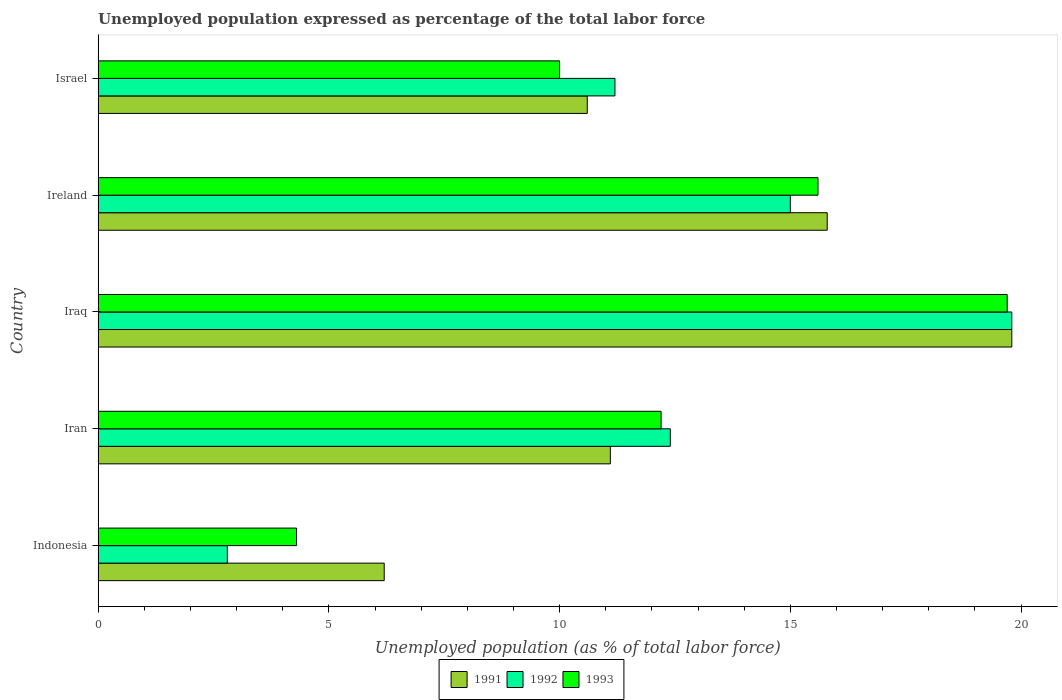How many different coloured bars are there?
Provide a short and direct response. 3. Are the number of bars on each tick of the Y-axis equal?
Provide a succinct answer. Yes. How many bars are there on the 2nd tick from the top?
Offer a terse response. 3. What is the label of the 4th group of bars from the top?
Your answer should be compact. Iran. In how many cases, is the number of bars for a given country not equal to the number of legend labels?
Keep it short and to the point. 0. What is the unemployment in in 1991 in Iraq?
Your answer should be compact. 19.8. Across all countries, what is the maximum unemployment in in 1991?
Provide a succinct answer. 19.8. Across all countries, what is the minimum unemployment in in 1991?
Give a very brief answer. 6.2. In which country was the unemployment in in 1992 maximum?
Your answer should be very brief. Iraq. What is the total unemployment in in 1993 in the graph?
Your answer should be very brief. 61.8. What is the difference between the unemployment in in 1993 in Iran and that in Ireland?
Provide a succinct answer. -3.4. What is the difference between the unemployment in in 1991 in Iraq and the unemployment in in 1993 in Ireland?
Make the answer very short. 4.2. What is the average unemployment in in 1991 per country?
Your answer should be compact. 12.7. What is the difference between the unemployment in in 1992 and unemployment in in 1993 in Iraq?
Your answer should be compact. 0.1. What is the ratio of the unemployment in in 1992 in Iran to that in Ireland?
Your answer should be compact. 0.83. Is the unemployment in in 1992 in Iraq less than that in Israel?
Provide a succinct answer. No. What is the difference between the highest and the second highest unemployment in in 1992?
Provide a short and direct response. 4.8. What is the difference between the highest and the lowest unemployment in in 1993?
Provide a short and direct response. 15.4. What does the 3rd bar from the bottom in Iran represents?
Offer a terse response. 1993. Is it the case that in every country, the sum of the unemployment in in 1993 and unemployment in in 1992 is greater than the unemployment in in 1991?
Provide a short and direct response. Yes. How many bars are there?
Ensure brevity in your answer.  15. Are all the bars in the graph horizontal?
Offer a very short reply. Yes. Does the graph contain any zero values?
Make the answer very short. No. What is the title of the graph?
Your answer should be compact. Unemployed population expressed as percentage of the total labor force. Does "2005" appear as one of the legend labels in the graph?
Keep it short and to the point. No. What is the label or title of the X-axis?
Ensure brevity in your answer.  Unemployed population (as % of total labor force). What is the Unemployed population (as % of total labor force) of 1991 in Indonesia?
Offer a very short reply. 6.2. What is the Unemployed population (as % of total labor force) in 1992 in Indonesia?
Ensure brevity in your answer.  2.8. What is the Unemployed population (as % of total labor force) of 1993 in Indonesia?
Provide a short and direct response. 4.3. What is the Unemployed population (as % of total labor force) of 1991 in Iran?
Offer a terse response. 11.1. What is the Unemployed population (as % of total labor force) of 1992 in Iran?
Keep it short and to the point. 12.4. What is the Unemployed population (as % of total labor force) of 1993 in Iran?
Your answer should be compact. 12.2. What is the Unemployed population (as % of total labor force) of 1991 in Iraq?
Make the answer very short. 19.8. What is the Unemployed population (as % of total labor force) of 1992 in Iraq?
Offer a very short reply. 19.8. What is the Unemployed population (as % of total labor force) of 1993 in Iraq?
Your answer should be very brief. 19.7. What is the Unemployed population (as % of total labor force) of 1991 in Ireland?
Make the answer very short. 15.8. What is the Unemployed population (as % of total labor force) in 1992 in Ireland?
Your answer should be compact. 15. What is the Unemployed population (as % of total labor force) of 1993 in Ireland?
Your answer should be very brief. 15.6. What is the Unemployed population (as % of total labor force) of 1991 in Israel?
Your response must be concise. 10.6. What is the Unemployed population (as % of total labor force) in 1992 in Israel?
Your response must be concise. 11.2. Across all countries, what is the maximum Unemployed population (as % of total labor force) of 1991?
Keep it short and to the point. 19.8. Across all countries, what is the maximum Unemployed population (as % of total labor force) in 1992?
Your answer should be very brief. 19.8. Across all countries, what is the maximum Unemployed population (as % of total labor force) of 1993?
Give a very brief answer. 19.7. Across all countries, what is the minimum Unemployed population (as % of total labor force) in 1991?
Provide a short and direct response. 6.2. Across all countries, what is the minimum Unemployed population (as % of total labor force) in 1992?
Provide a short and direct response. 2.8. Across all countries, what is the minimum Unemployed population (as % of total labor force) of 1993?
Ensure brevity in your answer.  4.3. What is the total Unemployed population (as % of total labor force) of 1991 in the graph?
Your answer should be compact. 63.5. What is the total Unemployed population (as % of total labor force) of 1992 in the graph?
Give a very brief answer. 61.2. What is the total Unemployed population (as % of total labor force) of 1993 in the graph?
Your answer should be compact. 61.8. What is the difference between the Unemployed population (as % of total labor force) in 1992 in Indonesia and that in Iran?
Provide a short and direct response. -9.6. What is the difference between the Unemployed population (as % of total labor force) in 1993 in Indonesia and that in Iran?
Give a very brief answer. -7.9. What is the difference between the Unemployed population (as % of total labor force) of 1992 in Indonesia and that in Iraq?
Give a very brief answer. -17. What is the difference between the Unemployed population (as % of total labor force) of 1993 in Indonesia and that in Iraq?
Provide a succinct answer. -15.4. What is the difference between the Unemployed population (as % of total labor force) in 1991 in Indonesia and that in Ireland?
Provide a short and direct response. -9.6. What is the difference between the Unemployed population (as % of total labor force) in 1992 in Indonesia and that in Ireland?
Ensure brevity in your answer.  -12.2. What is the difference between the Unemployed population (as % of total labor force) of 1993 in Indonesia and that in Ireland?
Keep it short and to the point. -11.3. What is the difference between the Unemployed population (as % of total labor force) in 1991 in Indonesia and that in Israel?
Offer a very short reply. -4.4. What is the difference between the Unemployed population (as % of total labor force) of 1992 in Indonesia and that in Israel?
Your response must be concise. -8.4. What is the difference between the Unemployed population (as % of total labor force) in 1991 in Iran and that in Iraq?
Offer a terse response. -8.7. What is the difference between the Unemployed population (as % of total labor force) in 1993 in Iran and that in Iraq?
Your answer should be compact. -7.5. What is the difference between the Unemployed population (as % of total labor force) of 1993 in Iraq and that in Ireland?
Your answer should be very brief. 4.1. What is the difference between the Unemployed population (as % of total labor force) of 1991 in Iraq and that in Israel?
Provide a short and direct response. 9.2. What is the difference between the Unemployed population (as % of total labor force) in 1991 in Ireland and that in Israel?
Keep it short and to the point. 5.2. What is the difference between the Unemployed population (as % of total labor force) in 1992 in Ireland and that in Israel?
Keep it short and to the point. 3.8. What is the difference between the Unemployed population (as % of total labor force) of 1991 in Indonesia and the Unemployed population (as % of total labor force) of 1992 in Iran?
Ensure brevity in your answer.  -6.2. What is the difference between the Unemployed population (as % of total labor force) in 1991 in Indonesia and the Unemployed population (as % of total labor force) in 1993 in Iran?
Keep it short and to the point. -6. What is the difference between the Unemployed population (as % of total labor force) of 1992 in Indonesia and the Unemployed population (as % of total labor force) of 1993 in Iran?
Give a very brief answer. -9.4. What is the difference between the Unemployed population (as % of total labor force) in 1991 in Indonesia and the Unemployed population (as % of total labor force) in 1993 in Iraq?
Ensure brevity in your answer.  -13.5. What is the difference between the Unemployed population (as % of total labor force) in 1992 in Indonesia and the Unemployed population (as % of total labor force) in 1993 in Iraq?
Provide a short and direct response. -16.9. What is the difference between the Unemployed population (as % of total labor force) in 1991 in Indonesia and the Unemployed population (as % of total labor force) in 1993 in Ireland?
Provide a succinct answer. -9.4. What is the difference between the Unemployed population (as % of total labor force) in 1992 in Indonesia and the Unemployed population (as % of total labor force) in 1993 in Ireland?
Provide a short and direct response. -12.8. What is the difference between the Unemployed population (as % of total labor force) in 1992 in Iran and the Unemployed population (as % of total labor force) in 1993 in Iraq?
Keep it short and to the point. -7.3. What is the difference between the Unemployed population (as % of total labor force) of 1991 in Iran and the Unemployed population (as % of total labor force) of 1992 in Ireland?
Your answer should be compact. -3.9. What is the difference between the Unemployed population (as % of total labor force) in 1992 in Iran and the Unemployed population (as % of total labor force) in 1993 in Ireland?
Your answer should be very brief. -3.2. What is the difference between the Unemployed population (as % of total labor force) in 1991 in Iran and the Unemployed population (as % of total labor force) in 1992 in Israel?
Make the answer very short. -0.1. What is the difference between the Unemployed population (as % of total labor force) of 1991 in Iraq and the Unemployed population (as % of total labor force) of 1993 in Ireland?
Ensure brevity in your answer.  4.2. What is the difference between the Unemployed population (as % of total labor force) of 1992 in Iraq and the Unemployed population (as % of total labor force) of 1993 in Israel?
Keep it short and to the point. 9.8. What is the difference between the Unemployed population (as % of total labor force) of 1991 in Ireland and the Unemployed population (as % of total labor force) of 1992 in Israel?
Give a very brief answer. 4.6. What is the difference between the Unemployed population (as % of total labor force) of 1991 in Ireland and the Unemployed population (as % of total labor force) of 1993 in Israel?
Your answer should be very brief. 5.8. What is the difference between the Unemployed population (as % of total labor force) of 1992 in Ireland and the Unemployed population (as % of total labor force) of 1993 in Israel?
Provide a short and direct response. 5. What is the average Unemployed population (as % of total labor force) in 1991 per country?
Provide a short and direct response. 12.7. What is the average Unemployed population (as % of total labor force) of 1992 per country?
Offer a terse response. 12.24. What is the average Unemployed population (as % of total labor force) in 1993 per country?
Provide a short and direct response. 12.36. What is the difference between the Unemployed population (as % of total labor force) in 1991 and Unemployed population (as % of total labor force) in 1992 in Indonesia?
Your answer should be very brief. 3.4. What is the difference between the Unemployed population (as % of total labor force) of 1991 and Unemployed population (as % of total labor force) of 1993 in Indonesia?
Your answer should be compact. 1.9. What is the difference between the Unemployed population (as % of total labor force) of 1992 and Unemployed population (as % of total labor force) of 1993 in Indonesia?
Your answer should be compact. -1.5. What is the difference between the Unemployed population (as % of total labor force) in 1992 and Unemployed population (as % of total labor force) in 1993 in Iran?
Ensure brevity in your answer.  0.2. What is the difference between the Unemployed population (as % of total labor force) in 1991 and Unemployed population (as % of total labor force) in 1992 in Iraq?
Offer a very short reply. 0. What is the difference between the Unemployed population (as % of total labor force) of 1991 and Unemployed population (as % of total labor force) of 1993 in Iraq?
Make the answer very short. 0.1. What is the difference between the Unemployed population (as % of total labor force) in 1991 and Unemployed population (as % of total labor force) in 1992 in Ireland?
Give a very brief answer. 0.8. What is the difference between the Unemployed population (as % of total labor force) in 1991 and Unemployed population (as % of total labor force) in 1993 in Ireland?
Your response must be concise. 0.2. What is the difference between the Unemployed population (as % of total labor force) in 1992 and Unemployed population (as % of total labor force) in 1993 in Ireland?
Offer a terse response. -0.6. What is the difference between the Unemployed population (as % of total labor force) in 1991 and Unemployed population (as % of total labor force) in 1993 in Israel?
Offer a very short reply. 0.6. What is the difference between the Unemployed population (as % of total labor force) in 1992 and Unemployed population (as % of total labor force) in 1993 in Israel?
Give a very brief answer. 1.2. What is the ratio of the Unemployed population (as % of total labor force) of 1991 in Indonesia to that in Iran?
Your answer should be very brief. 0.56. What is the ratio of the Unemployed population (as % of total labor force) of 1992 in Indonesia to that in Iran?
Provide a succinct answer. 0.23. What is the ratio of the Unemployed population (as % of total labor force) in 1993 in Indonesia to that in Iran?
Your answer should be very brief. 0.35. What is the ratio of the Unemployed population (as % of total labor force) in 1991 in Indonesia to that in Iraq?
Keep it short and to the point. 0.31. What is the ratio of the Unemployed population (as % of total labor force) of 1992 in Indonesia to that in Iraq?
Your answer should be very brief. 0.14. What is the ratio of the Unemployed population (as % of total labor force) of 1993 in Indonesia to that in Iraq?
Offer a very short reply. 0.22. What is the ratio of the Unemployed population (as % of total labor force) in 1991 in Indonesia to that in Ireland?
Provide a succinct answer. 0.39. What is the ratio of the Unemployed population (as % of total labor force) in 1992 in Indonesia to that in Ireland?
Give a very brief answer. 0.19. What is the ratio of the Unemployed population (as % of total labor force) of 1993 in Indonesia to that in Ireland?
Make the answer very short. 0.28. What is the ratio of the Unemployed population (as % of total labor force) of 1991 in Indonesia to that in Israel?
Ensure brevity in your answer.  0.58. What is the ratio of the Unemployed population (as % of total labor force) of 1992 in Indonesia to that in Israel?
Provide a succinct answer. 0.25. What is the ratio of the Unemployed population (as % of total labor force) in 1993 in Indonesia to that in Israel?
Keep it short and to the point. 0.43. What is the ratio of the Unemployed population (as % of total labor force) of 1991 in Iran to that in Iraq?
Ensure brevity in your answer.  0.56. What is the ratio of the Unemployed population (as % of total labor force) of 1992 in Iran to that in Iraq?
Ensure brevity in your answer.  0.63. What is the ratio of the Unemployed population (as % of total labor force) of 1993 in Iran to that in Iraq?
Provide a short and direct response. 0.62. What is the ratio of the Unemployed population (as % of total labor force) in 1991 in Iran to that in Ireland?
Your answer should be compact. 0.7. What is the ratio of the Unemployed population (as % of total labor force) of 1992 in Iran to that in Ireland?
Give a very brief answer. 0.83. What is the ratio of the Unemployed population (as % of total labor force) in 1993 in Iran to that in Ireland?
Give a very brief answer. 0.78. What is the ratio of the Unemployed population (as % of total labor force) in 1991 in Iran to that in Israel?
Your answer should be compact. 1.05. What is the ratio of the Unemployed population (as % of total labor force) in 1992 in Iran to that in Israel?
Your answer should be very brief. 1.11. What is the ratio of the Unemployed population (as % of total labor force) in 1993 in Iran to that in Israel?
Your response must be concise. 1.22. What is the ratio of the Unemployed population (as % of total labor force) of 1991 in Iraq to that in Ireland?
Keep it short and to the point. 1.25. What is the ratio of the Unemployed population (as % of total labor force) in 1992 in Iraq to that in Ireland?
Your response must be concise. 1.32. What is the ratio of the Unemployed population (as % of total labor force) in 1993 in Iraq to that in Ireland?
Keep it short and to the point. 1.26. What is the ratio of the Unemployed population (as % of total labor force) in 1991 in Iraq to that in Israel?
Your response must be concise. 1.87. What is the ratio of the Unemployed population (as % of total labor force) of 1992 in Iraq to that in Israel?
Your response must be concise. 1.77. What is the ratio of the Unemployed population (as % of total labor force) of 1993 in Iraq to that in Israel?
Keep it short and to the point. 1.97. What is the ratio of the Unemployed population (as % of total labor force) in 1991 in Ireland to that in Israel?
Your answer should be very brief. 1.49. What is the ratio of the Unemployed population (as % of total labor force) of 1992 in Ireland to that in Israel?
Offer a very short reply. 1.34. What is the ratio of the Unemployed population (as % of total labor force) of 1993 in Ireland to that in Israel?
Your answer should be very brief. 1.56. What is the difference between the highest and the second highest Unemployed population (as % of total labor force) in 1992?
Your answer should be very brief. 4.8. What is the difference between the highest and the second highest Unemployed population (as % of total labor force) of 1993?
Give a very brief answer. 4.1. What is the difference between the highest and the lowest Unemployed population (as % of total labor force) in 1991?
Provide a succinct answer. 13.6. What is the difference between the highest and the lowest Unemployed population (as % of total labor force) in 1993?
Your answer should be very brief. 15.4. 